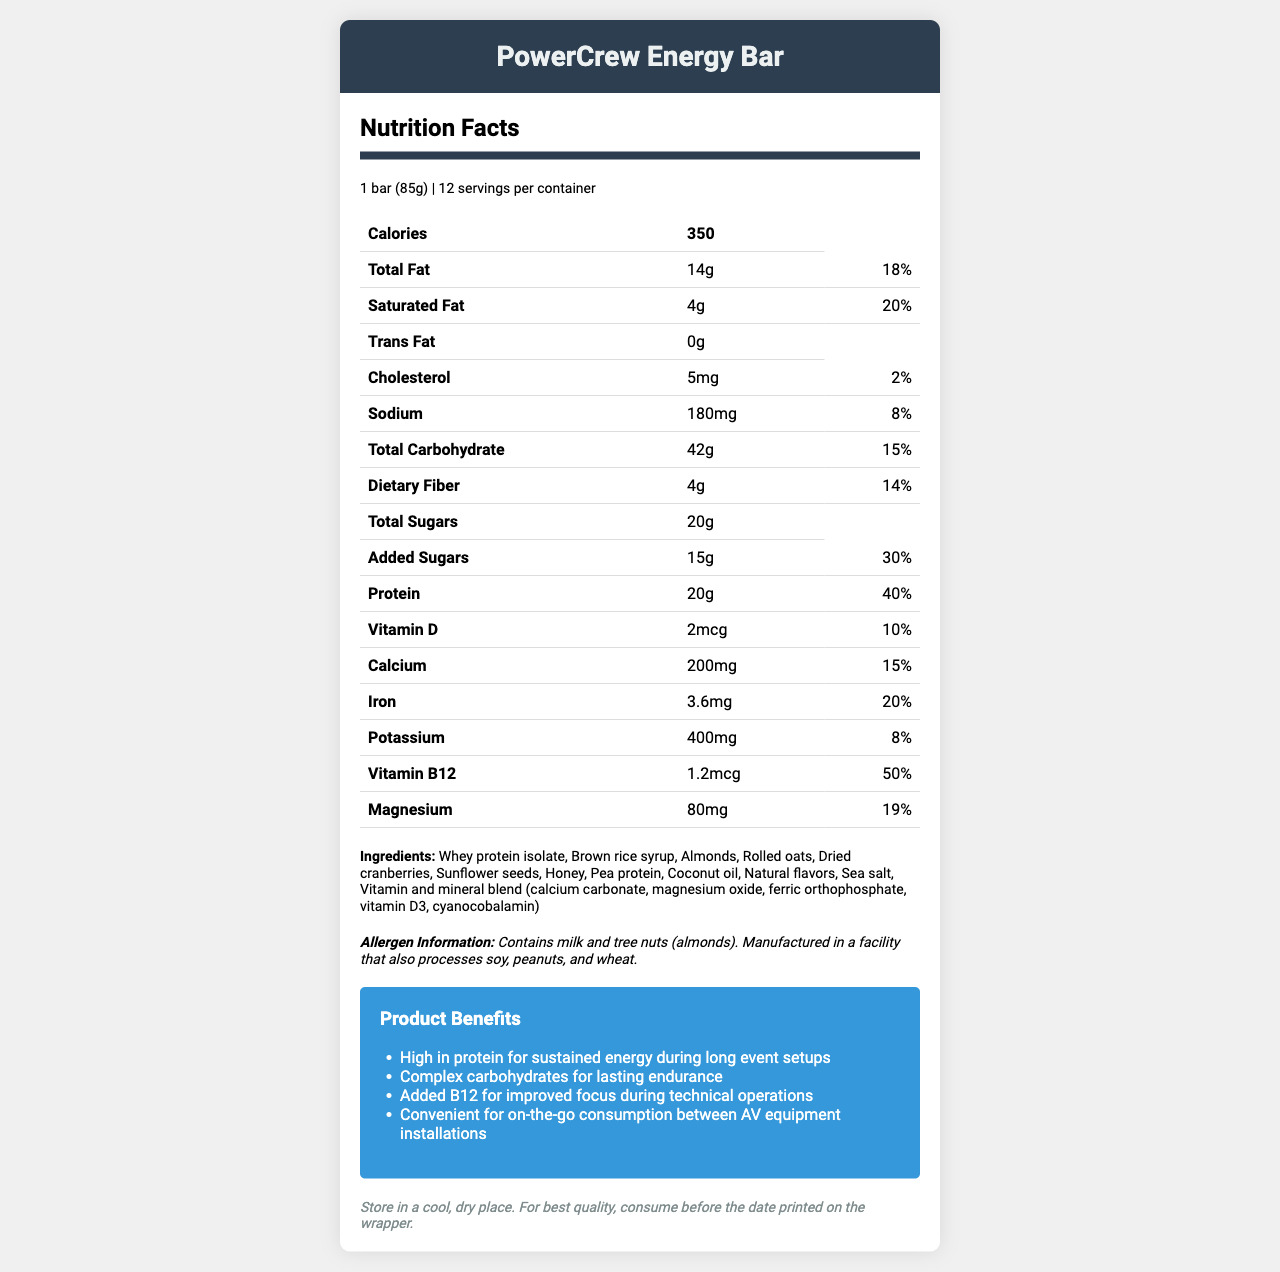what is the serving size of the PowerCrew Energy Bar? The serving size is listed at the very top of the nutrition facts section as "1 bar (85g)".
Answer: 1 bar (85g) how many servings are there per container? The servings per container are mentioned in the serving information section, stating "12 servings per container".
Answer: 12 how many grams of protein does one serving contain? The amount of protein per serving is listed in the nutrition facts table as "20g".
Answer: 20g what percentage of the daily value of protein does one serving provide? The nutrition facts table shows 40% as the daily value for protein.
Answer: 40% list three ingredients found in PowerCrew Energy Bar. The ingredients are listed in the ingredients section, and three examples from that list are Whey protein isolate, Brown rice syrup, and Almonds.
Answer: Whey protein isolate, Brown rice syrup, Almonds what is the amount of total sugars in one serving? The total sugars per serving are listed in the nutrition facts table as "20g".
Answer: 20g how much calcium is in one serving? The amount of calcium per serving is listed in the nutrition facts table as "200mg".
Answer: 200mg how much magnesium does one serving provide in terms of percentage of daily value? The nutrition facts table shows that one serving provides 19% of the daily value for magnesium.
Answer: 19% According to the document, which of the following is a key reason PowerCrew Energy Bar is beneficial during long event setups? A. Low trans fat B. High protein C. Low calories D. Low sodium The marketing claims section mentions "High in protein for sustained energy during long event setups" as a key benefit.
Answer: B what is the suggested storage instruction for the PowerCrew Energy Bar? A. Store in a refrigerator B. Keep in a hot and moist place C. Store in a cool, dry place The storage instructions advise "Store in a cool, dry place."
Answer: C Does the PowerCrew Energy Bar contain peanuts? The allergen information states that while it contains milk and tree nuts (almonds), it does not mention peanuts as an ingredient but notes that it is manufactured in a facility that also processes peanuts.
Answer: No Summarize the primary nutritional benefits of the PowerCrew Energy Bar for an event crew member. The marketing claims outline the primary nutritional benefits as being high in protein for sustained energy, having complex carbohydrates for lasting endurance, and added B12 for improved focus.
Answer: High in protein, contains complex carbohydrates for endurance, added B12 for focus Is the exact expiration date of the PowerCrew Energy Bar provided in the document? The document mentions consuming the product before the date printed on the wrapper, but it does not provide the actual expiration date.
Answer: Not enough information what are the total calories in one serving of the PowerCrew Energy Bar? The total calories per serving are listed at the top of the nutrition facts table as "350".
Answer: 350 calories what is the percentage of daily value for iron in one serving? The nutrition facts table shows that one serving provides 20% of the daily value for iron.
Answer: 20% 